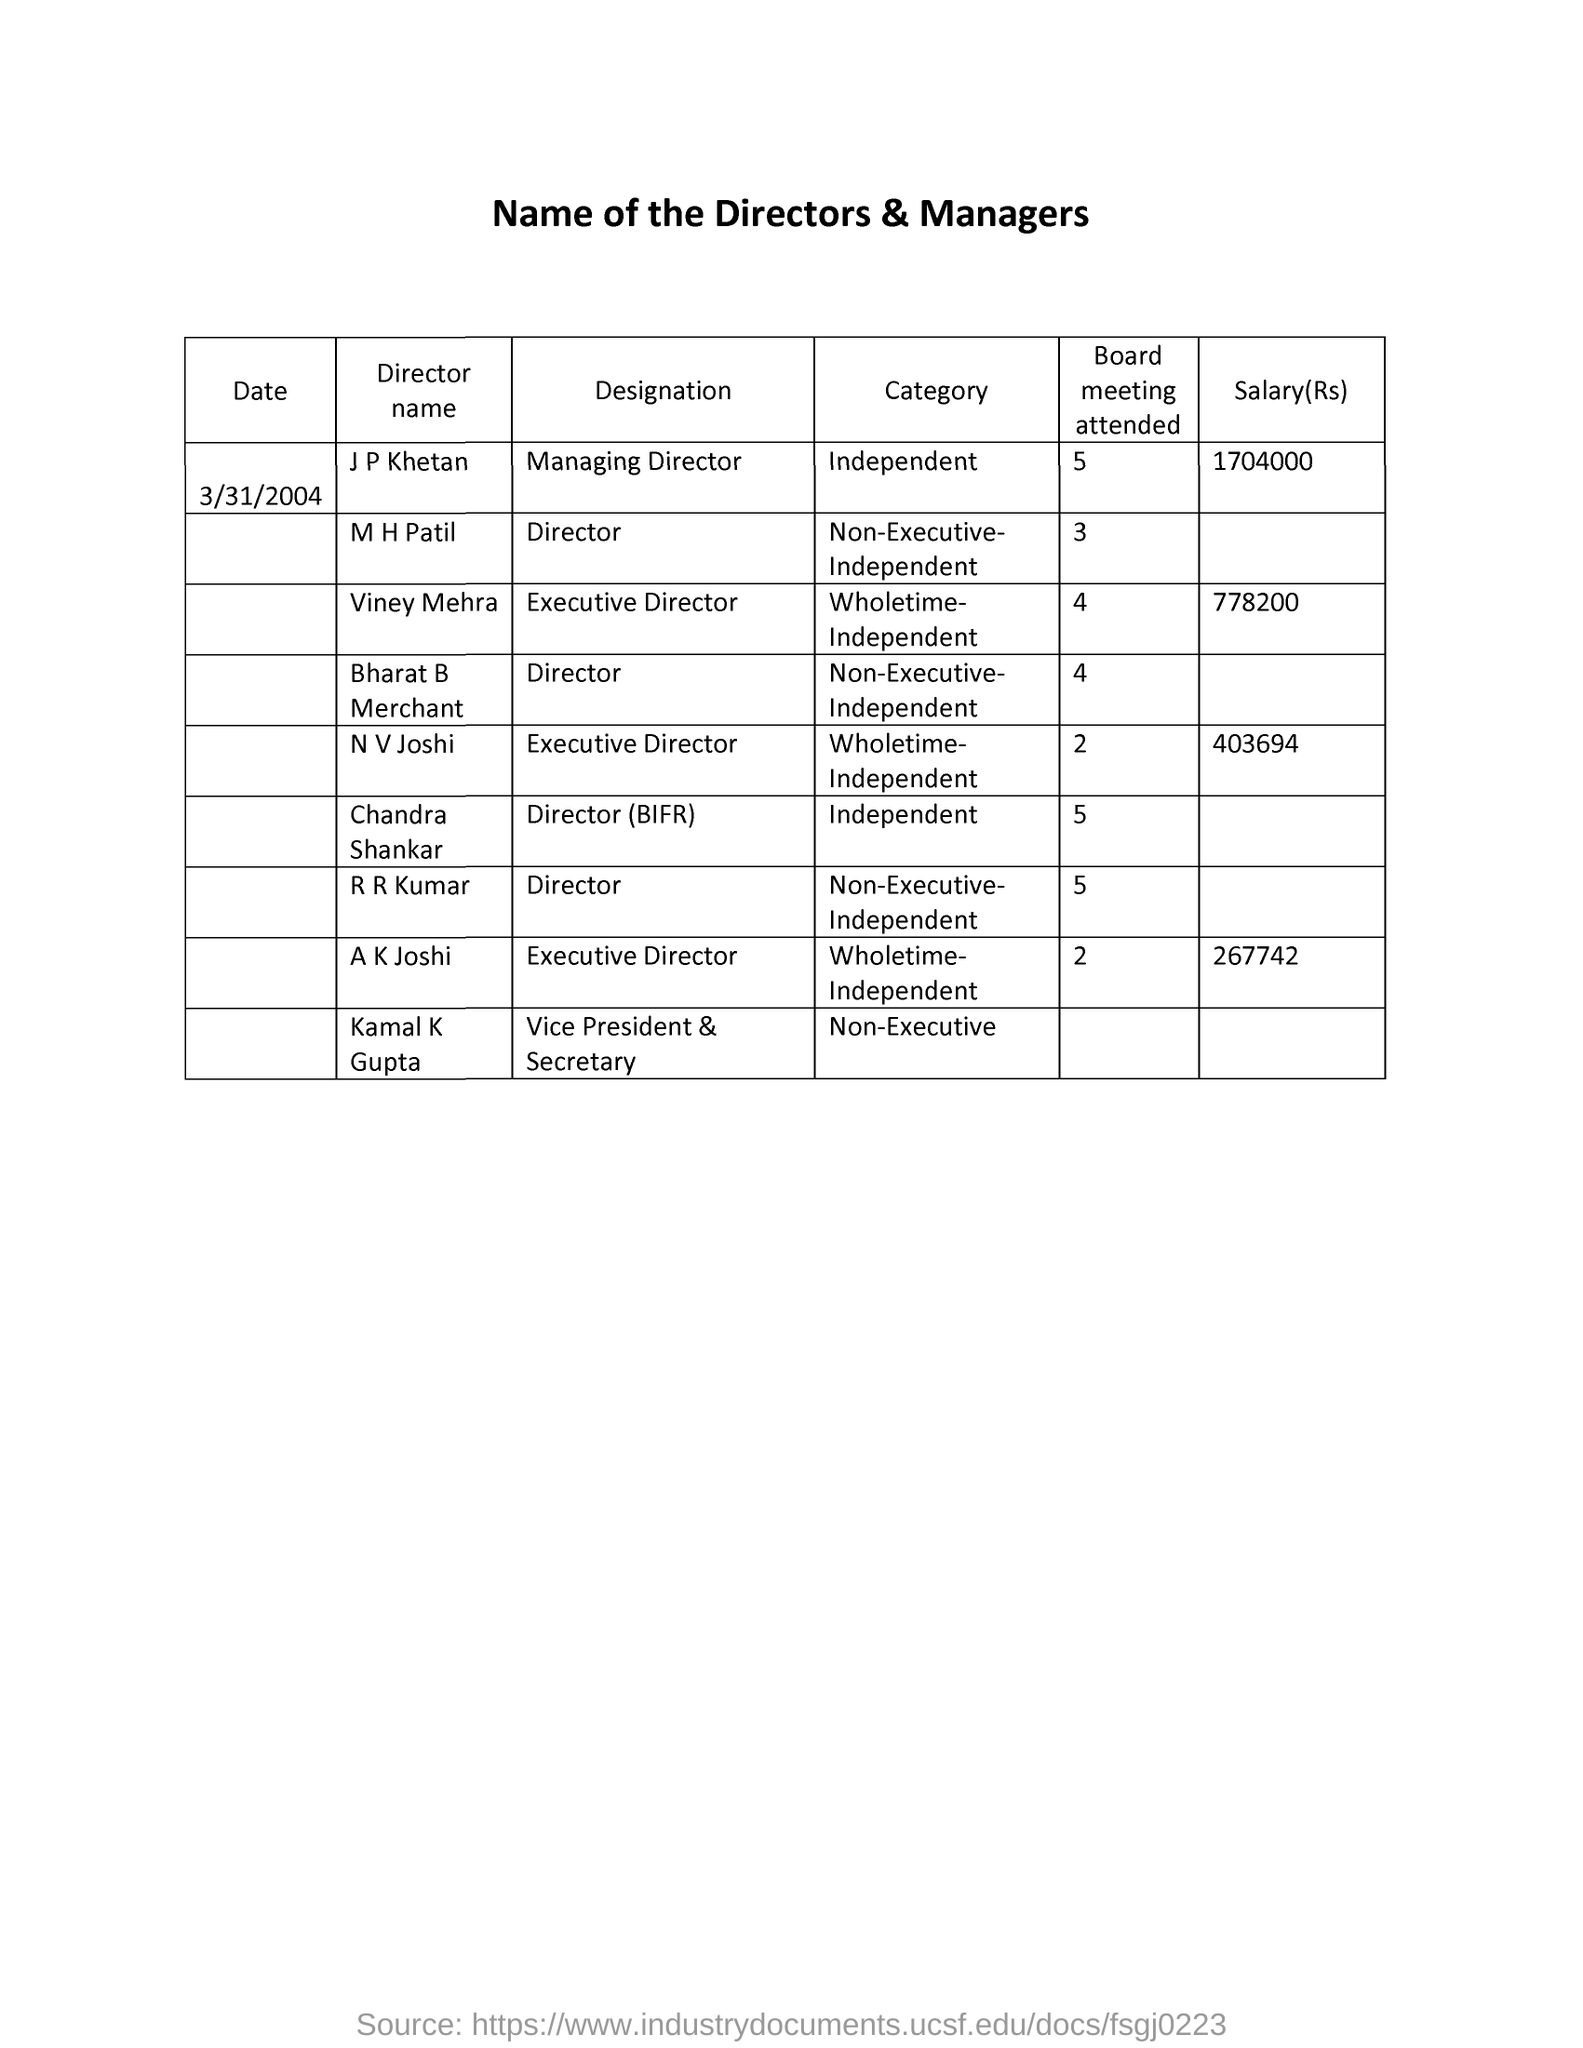Identify some key points in this picture. Viney Mehra is the Executive Director. The date mentioned is March 31, 2004. It has been determined that Kamal K Gupta is both the Vice President and Secretary of the organization. The salary of Viney Mehra is 778,200, Mahendra Patil has been designated as the Director of a company. 